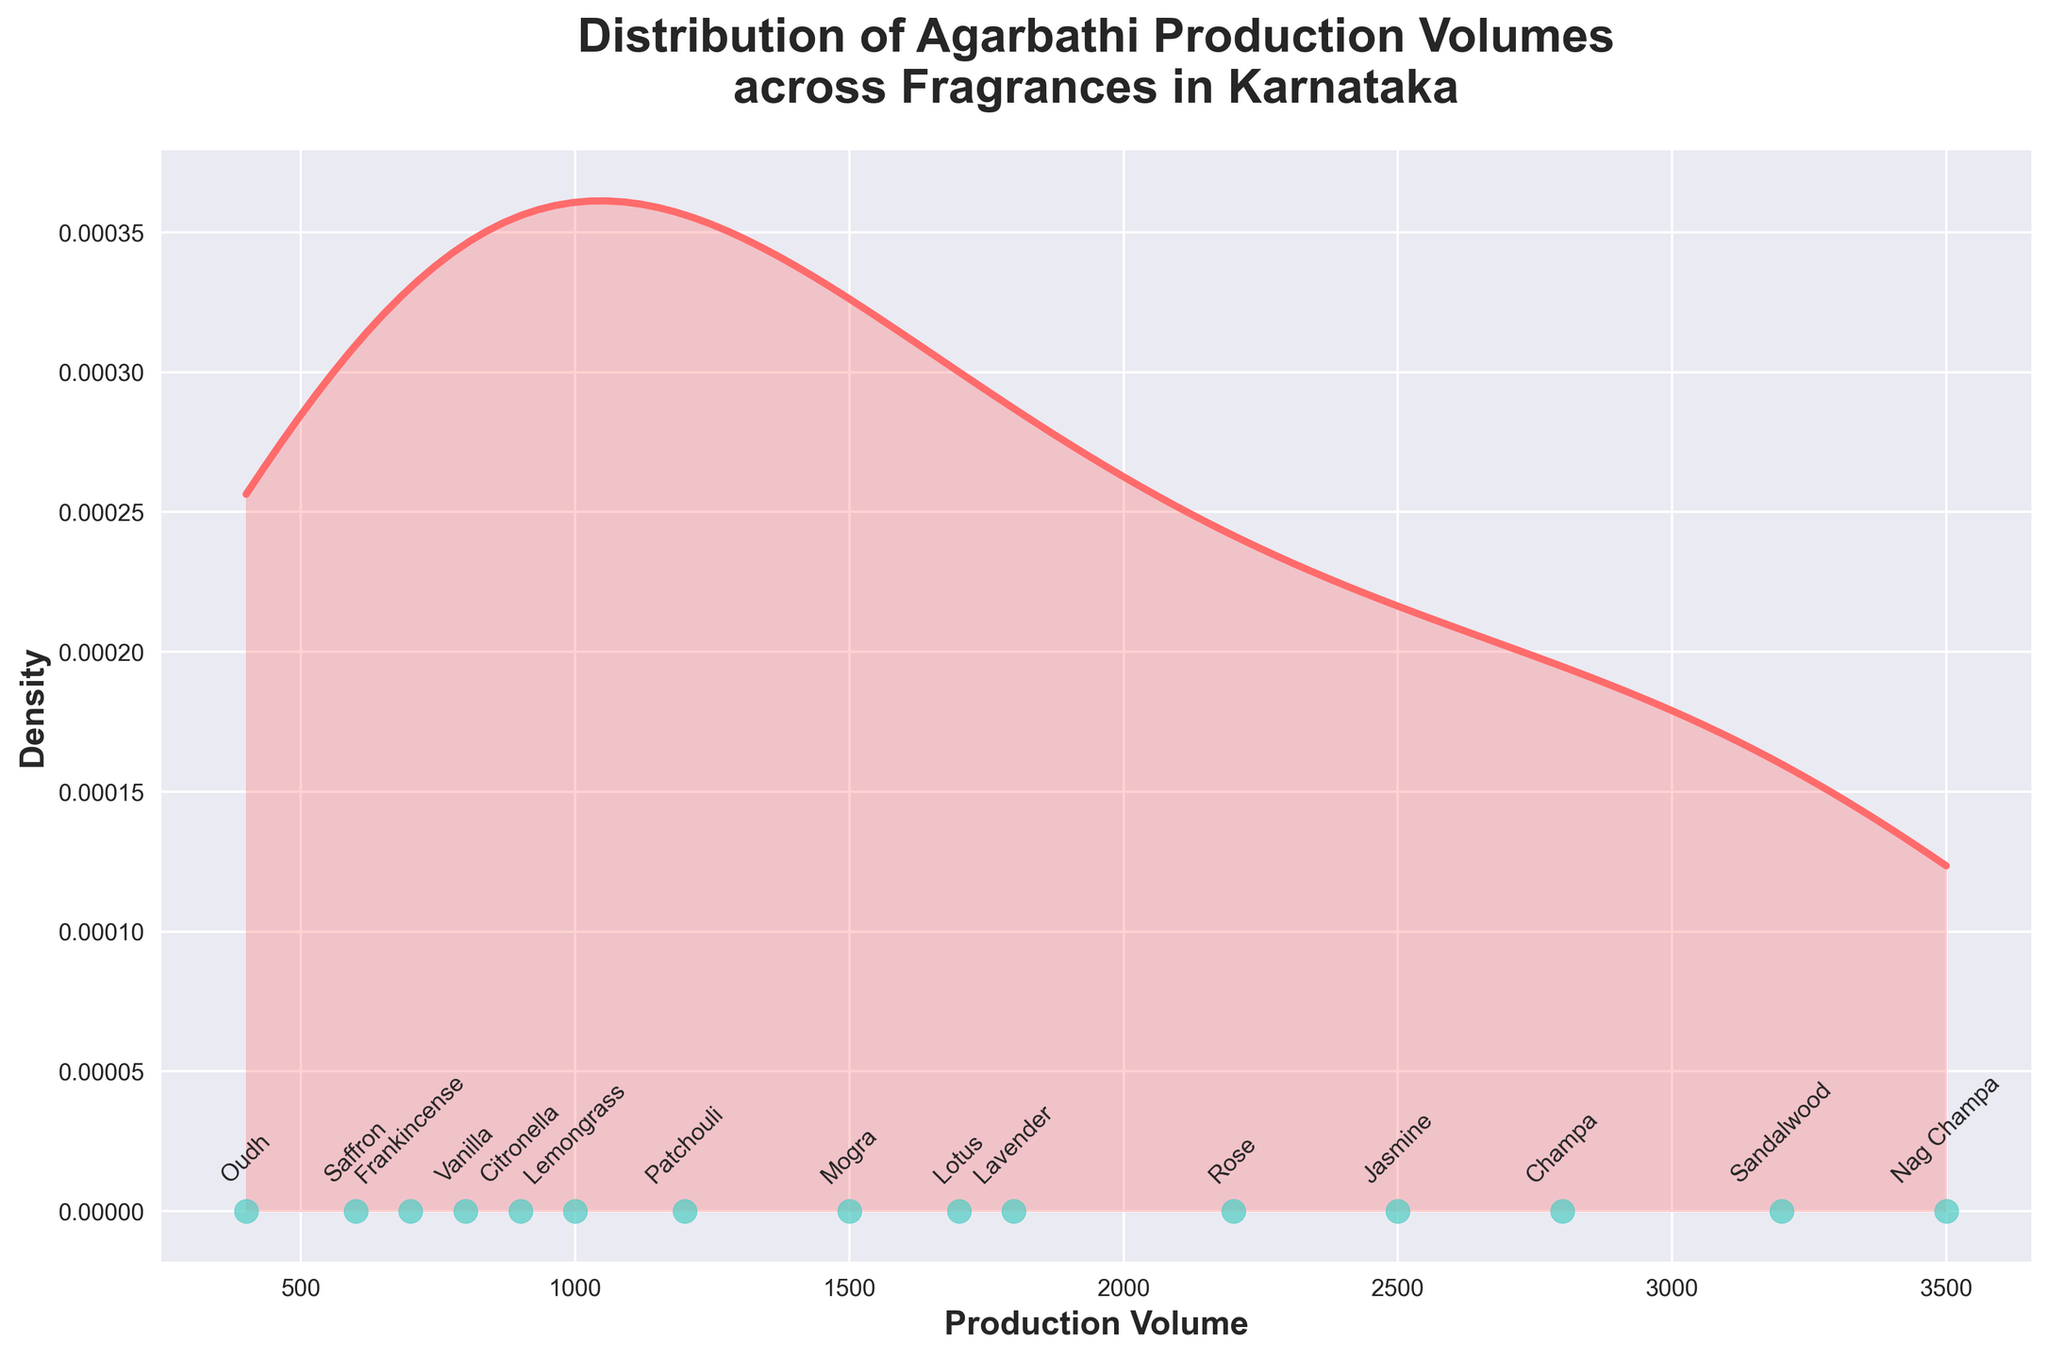What is the title of the plot? The title of the plot is located at the top of the figure and it gives an overview of what the data represents. From the figure, we can read the title directly.
Answer: Distribution of Agarbathi Production Volumes across Fragrances in Karnataka How many fragrances have their production volumes annotated in the plot? The plot has text annotations that label each fragrance corresponding to their production volumes. Count the labels to find the total number.
Answer: 15 Which fragrance has the highest production volume? By examining the scatter points and their corresponding annotations, identify the highest point on the horizontal axis and its label.
Answer: Nag Champa Which fragrance has the lowest production volume? Look at the scatter points on the leftmost side of the horizontal axis to identify the lowest value and its labeled fragrance.
Answer: Oudh What is the range of production volumes in the plot? The range is calculated by subtracting the smallest production volume from the largest. Determine the smallest (Oudh, 400) and the largest (Nag Champa, 3500) volumes. Range: 3500 - 400 = 3100.
Answer: 3100 Which fragrance is produced slightly more than Frankincense? Identify the scatter point for Frankincense, then look for the next immediate point, and read its corresponding fragrance label.
Answer: Citronella Is the Jasmine production volume closer to the lower or upper end of the range? Compare Jasmine's production volume (2500) to the mid-point of the entire range (1800). Since 2500 is closer to 3500 than to 400, it is near the upper end.
Answer: Upper end How does the production volume of Lavender compare to Lotus? Locate the scatter points and annotations for Lavender (1800) and Lotus (1700), then directly compare the two values.
Answer: Lavender is slightly higher than Lotus What can you infer from the density curve about the concentration of production volumes? The density curve shows the distribution of production volumes. Areas under the curve where it is higher represent where production volumes are more concentrated. The peak concentration is around the middle of the production volume range.
Answer: Most production volumes are around the middle range Which two fragrances have the nearest production volumes? Look for close scatter points on the horizontal axis and compare their labeled values. The nearest ones are Lavender (1800) and Lotus (1700), with a small difference.
Answer: Lavender and Lotus 